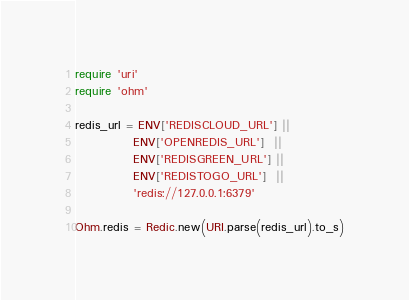<code> <loc_0><loc_0><loc_500><loc_500><_Ruby_>require 'uri'
require 'ohm'

redis_url = ENV['REDISCLOUD_URL'] ||
            ENV['OPENREDIS_URL']  ||
            ENV['REDISGREEN_URL'] ||
            ENV['REDISTOGO_URL']  ||
            'redis://127.0.0.1:6379'

Ohm.redis = Redic.new(URI.parse(redis_url).to_s)
</code> 